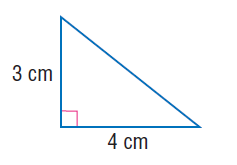Question: Use the Pythagorean Theorem to find the length of the hypotenuse of the right triangle.
Choices:
A. \sqrt { 7 }
B. 3
C. 4
D. 5
Answer with the letter. Answer: D 